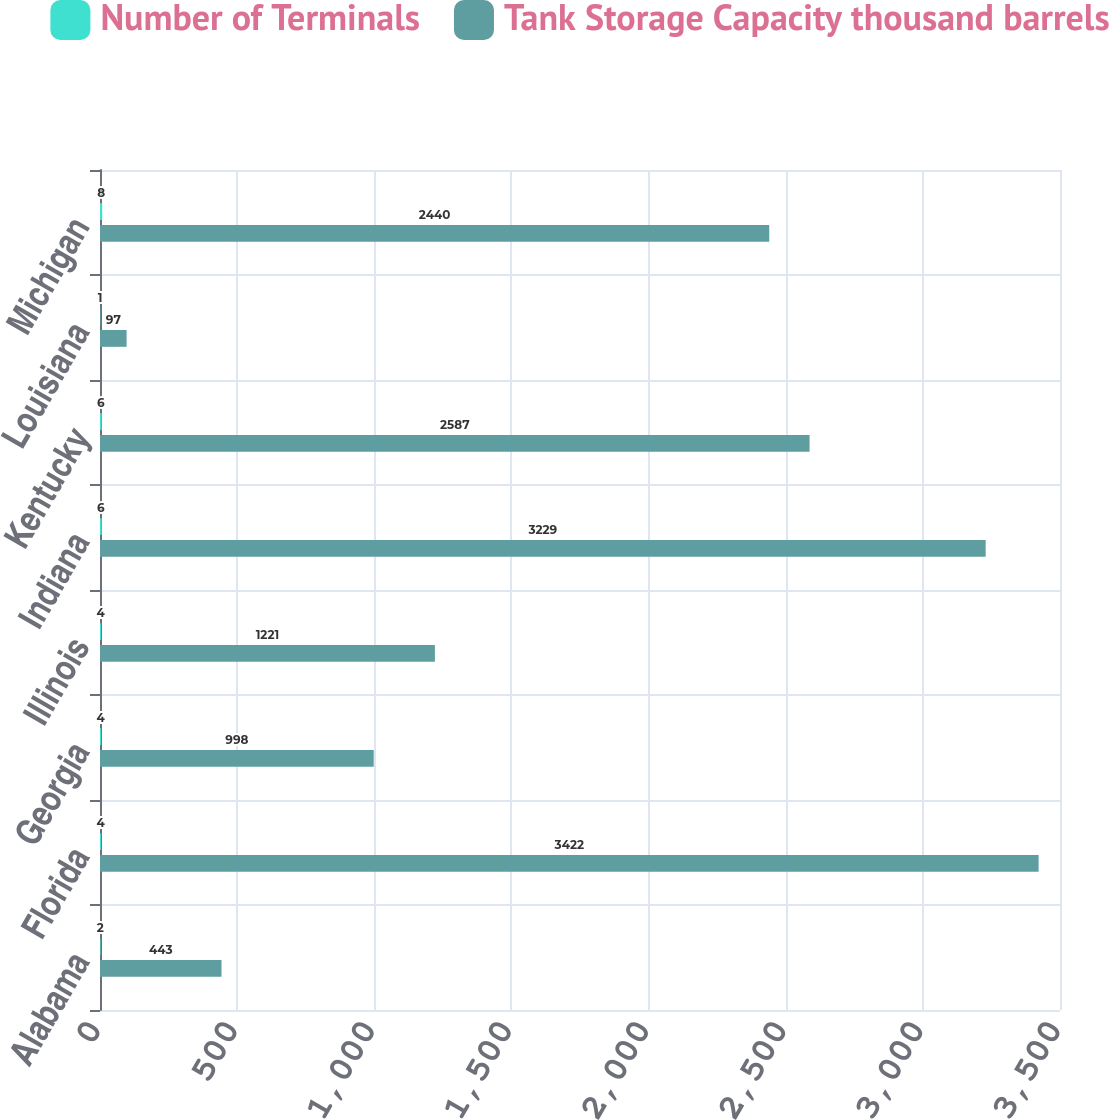Convert chart. <chart><loc_0><loc_0><loc_500><loc_500><stacked_bar_chart><ecel><fcel>Alabama<fcel>Florida<fcel>Georgia<fcel>Illinois<fcel>Indiana<fcel>Kentucky<fcel>Louisiana<fcel>Michigan<nl><fcel>Number of Terminals<fcel>2<fcel>4<fcel>4<fcel>4<fcel>6<fcel>6<fcel>1<fcel>8<nl><fcel>Tank Storage Capacity thousand barrels<fcel>443<fcel>3422<fcel>998<fcel>1221<fcel>3229<fcel>2587<fcel>97<fcel>2440<nl></chart> 